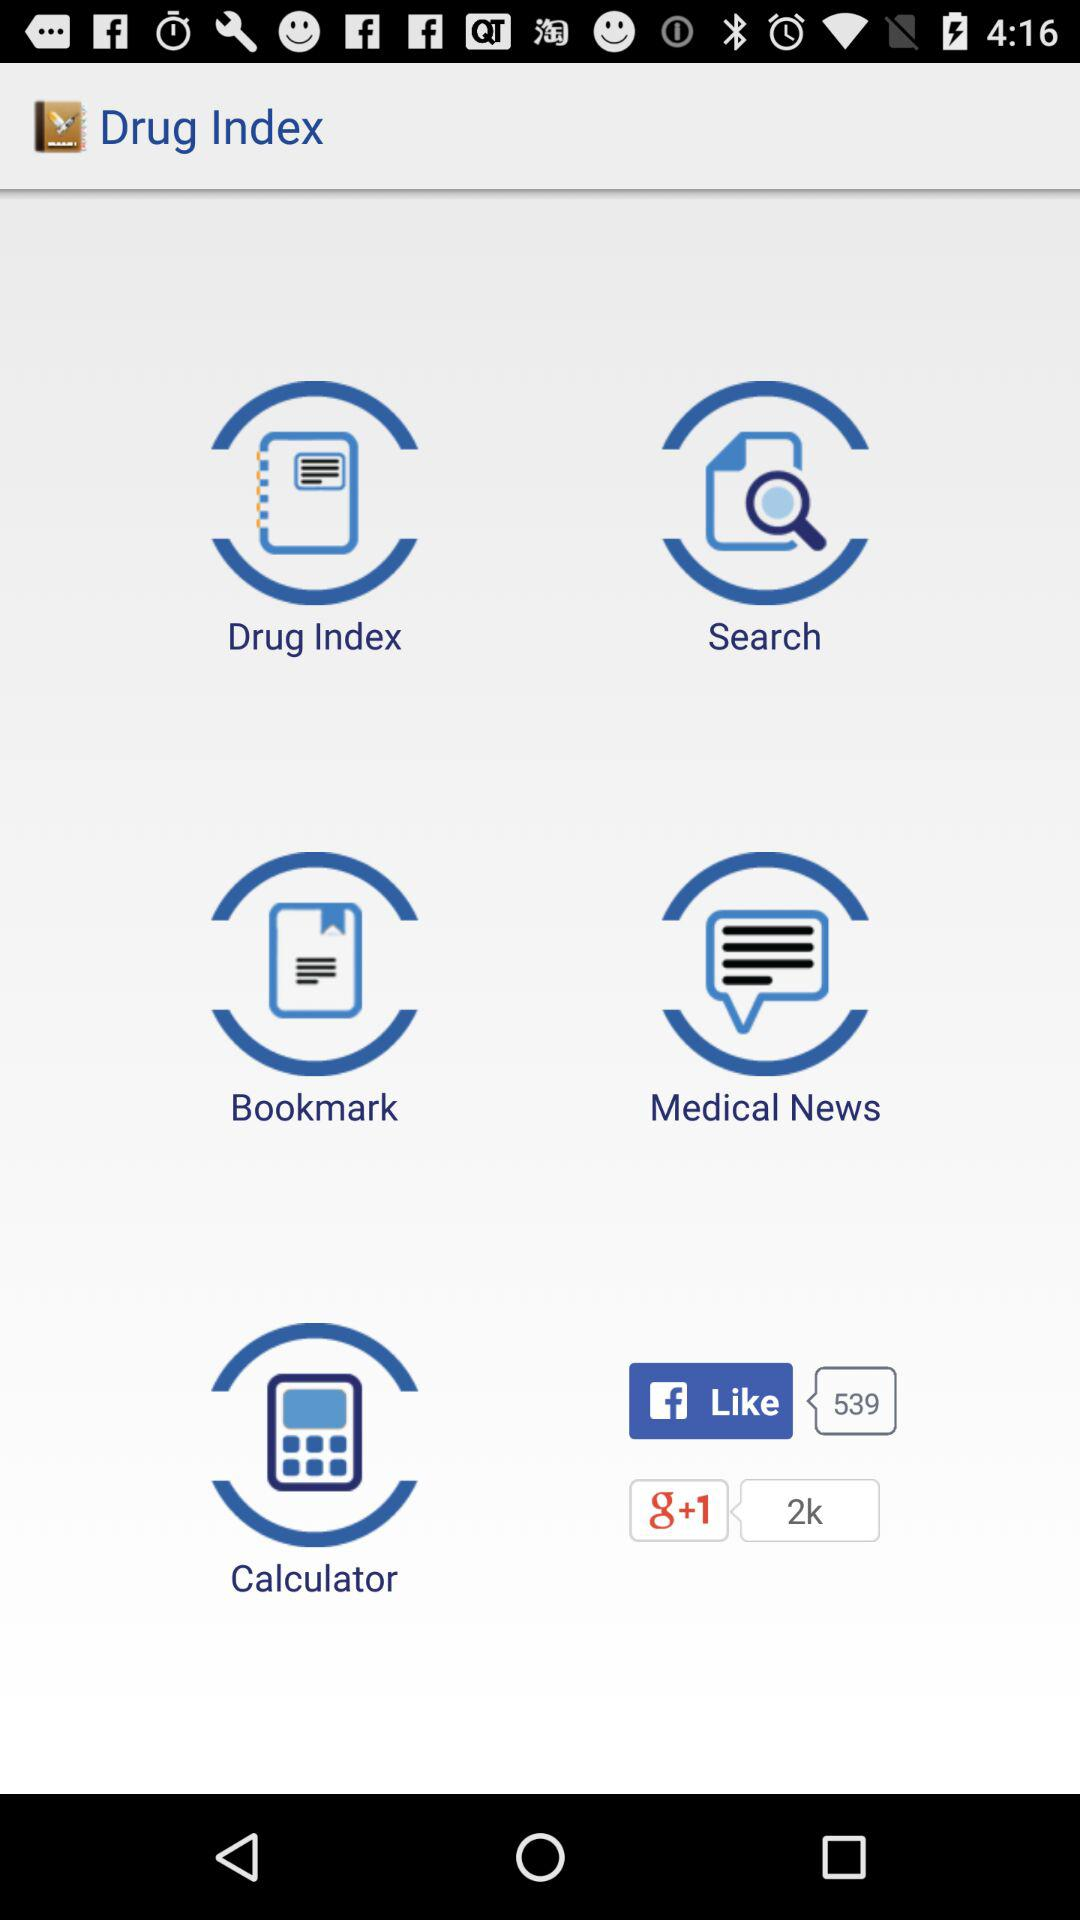How many Facebook likes are there? There are 539 Facebook likes. 